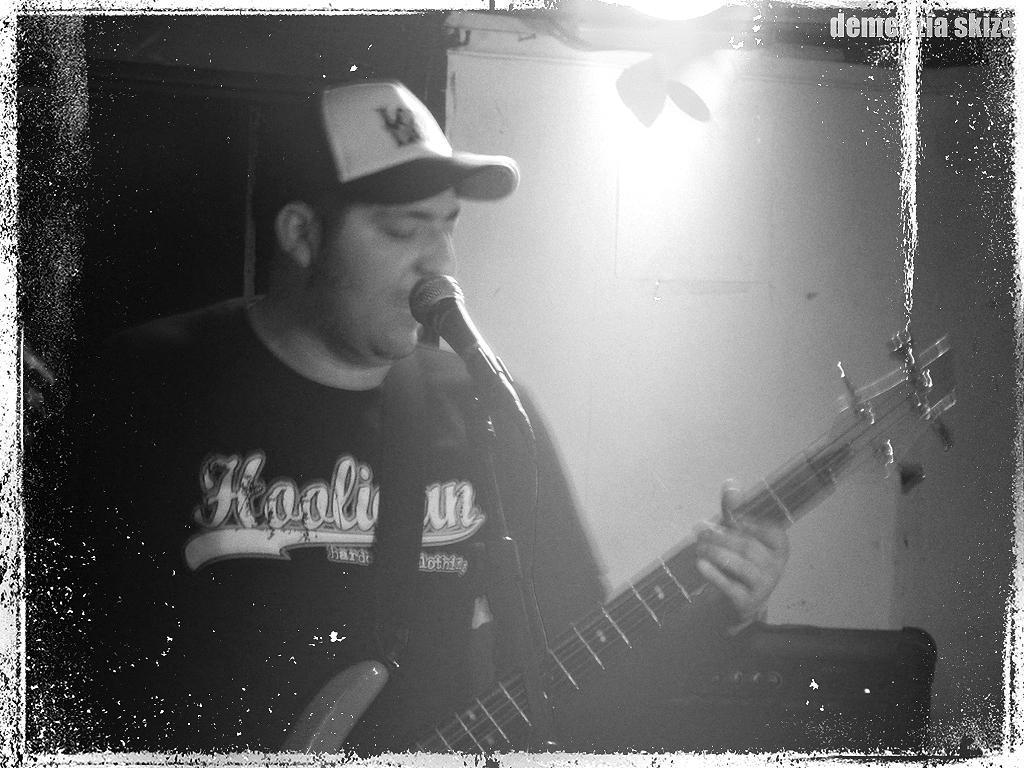Please provide a concise description of this image. In this image on the right there is a man he wears t shirt and cap he is singing he is playing guitar. In the background there is a wall. 